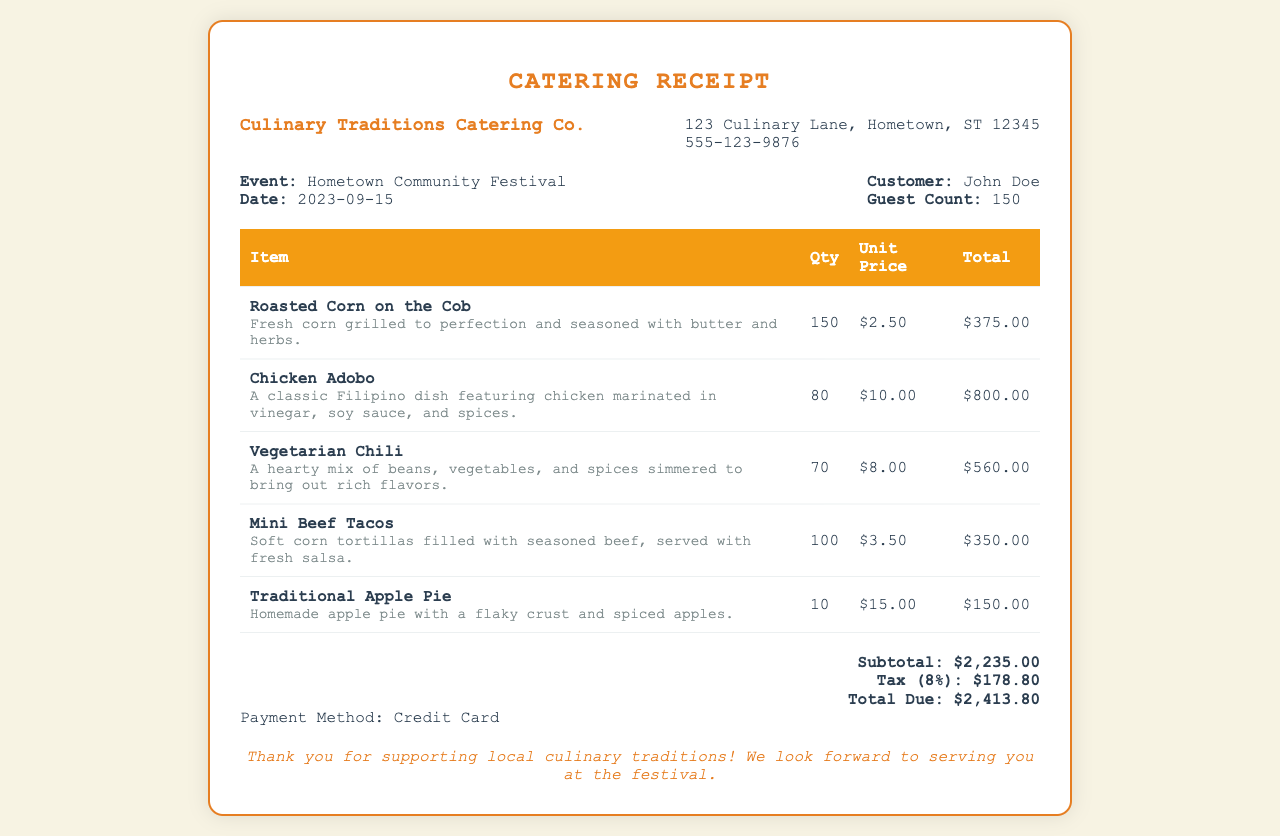What is the name of the catering company? The name of the catering company is displayed at the top of the receipt.
Answer: Culinary Traditions Catering Co What is the event date? The event date is mentioned in the customer info section.
Answer: 2023-09-15 How many guests were counted for the event? The guest count is indicated in the customer info section.
Answer: 150 What is the total due amount? The total due amount is calculated at the bottom of the receipt.
Answer: $2,413.80 What dish is described as having a flaky crust and spiced apples? This specific dish name is included in the table of menu items.
Answer: Traditional Apple Pie How much is charged per unit for Chicken Adobo? The unit price for Chicken Adobo is listed in the table.
Answer: $10.00 What is the subtotal before tax? The subtotal amount is shown just above the tax amount in the receipt.
Answer: $2,235.00 What is the payment method used for the catering service? The payment method is mentioned at the bottom of the document.
Answer: Credit Card How many total items of Vegetarian Chili were served? The quantity of Vegetarian Chili is recorded in the menu item table.
Answer: 70 